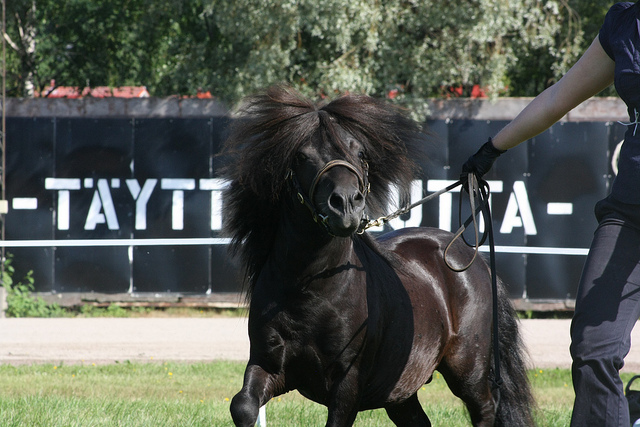Read all the text in this image. TAYTI 